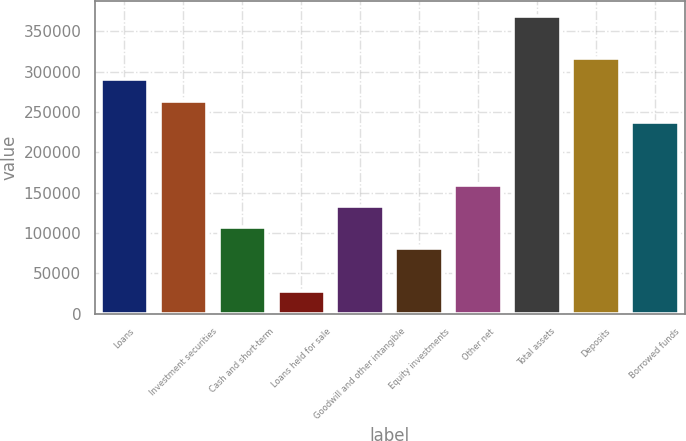<chart> <loc_0><loc_0><loc_500><loc_500><bar_chart><fcel>Loans<fcel>Investment securities<fcel>Cash and short-term<fcel>Loans held for sale<fcel>Goodwill and other intangible<fcel>Equity investments<fcel>Other net<fcel>Total assets<fcel>Deposits<fcel>Borrowed funds<nl><fcel>290453<fcel>264284<fcel>107271<fcel>28764.8<fcel>133440<fcel>81102.4<fcel>159609<fcel>368959<fcel>316622<fcel>238115<nl></chart> 